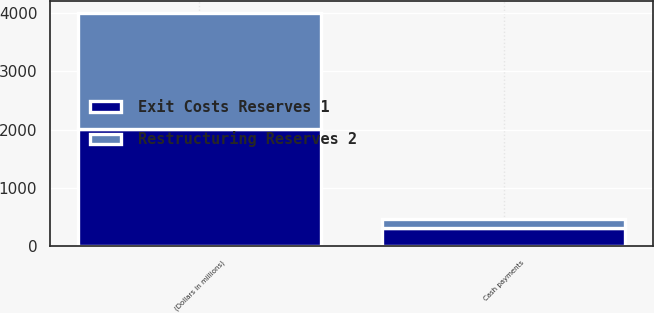<chart> <loc_0><loc_0><loc_500><loc_500><stacked_bar_chart><ecel><fcel>(Dollars in millions)<fcel>Cash payments<nl><fcel>Exit Costs Reserves 1<fcel>2005<fcel>306<nl><fcel>Restructuring Reserves 2<fcel>2005<fcel>151<nl></chart> 